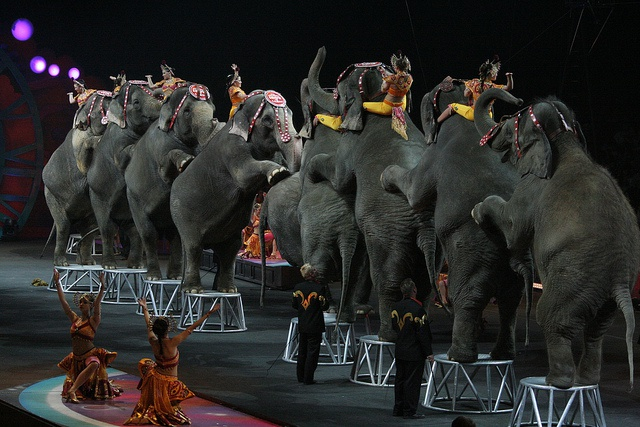Describe the objects in this image and their specific colors. I can see elephant in black and gray tones, elephant in black and gray tones, elephant in black and gray tones, elephant in black, gray, and darkgray tones, and elephant in black, gray, and darkgray tones in this image. 